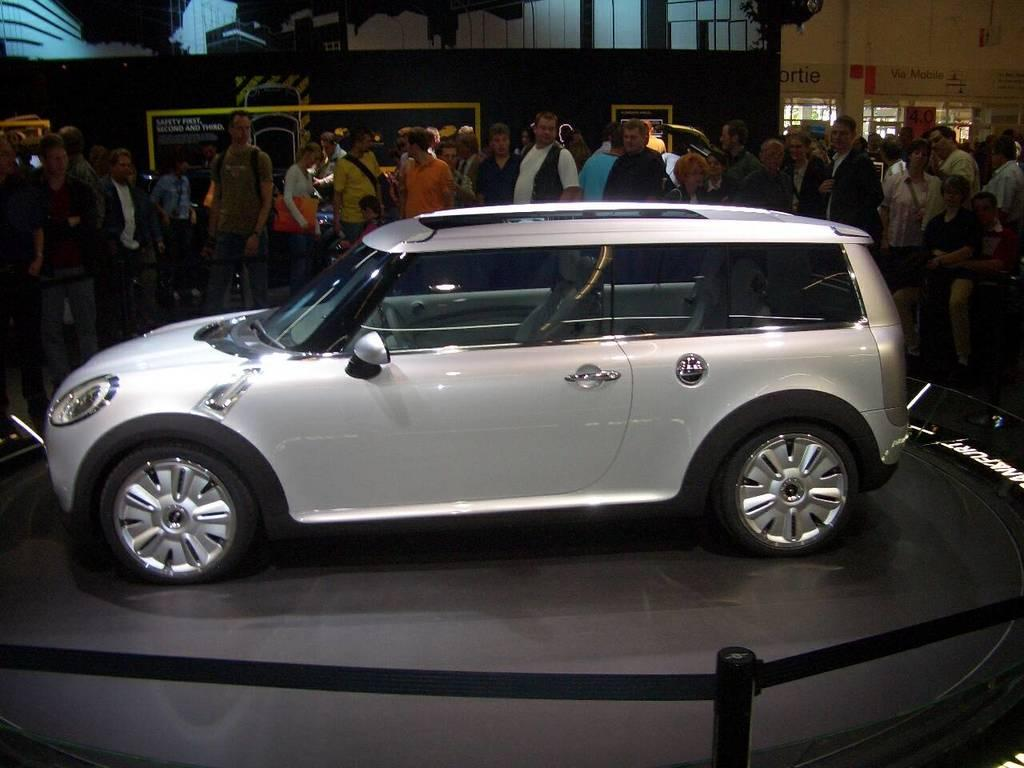What type of vehicle is in the image? There is a silver car in the image. Where is the car located? The car is parked in a showroom. Are there any people in the image? Yes, there are people standing and watching the car in the background. What verse can be seen written on the car in the image? There is no verse written on the car in the image; it is a silver car parked in a showroom. 